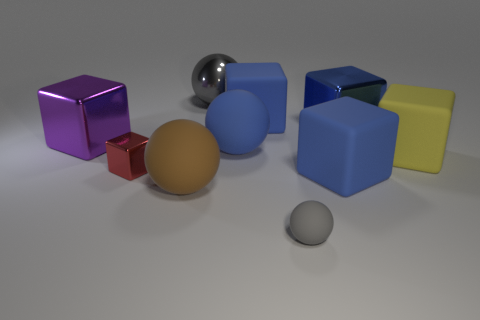Do the big metal ball and the small cube have the same color?
Your response must be concise. No. Is the number of small green balls less than the number of yellow rubber cubes?
Your answer should be compact. Yes. There is a small rubber sphere; are there any small red metallic blocks to the right of it?
Offer a very short reply. No. Do the small gray ball and the yellow thing have the same material?
Offer a very short reply. Yes. The other big metal object that is the same shape as the large purple shiny object is what color?
Provide a succinct answer. Blue. Does the large shiny block left of the large gray shiny sphere have the same color as the tiny matte thing?
Your response must be concise. No. The tiny object that is the same color as the large metallic sphere is what shape?
Your answer should be compact. Sphere. How many other blocks are made of the same material as the big yellow block?
Offer a very short reply. 2. There is a big yellow object; how many blue cubes are left of it?
Offer a terse response. 3. What size is the purple block?
Give a very brief answer. Large. 